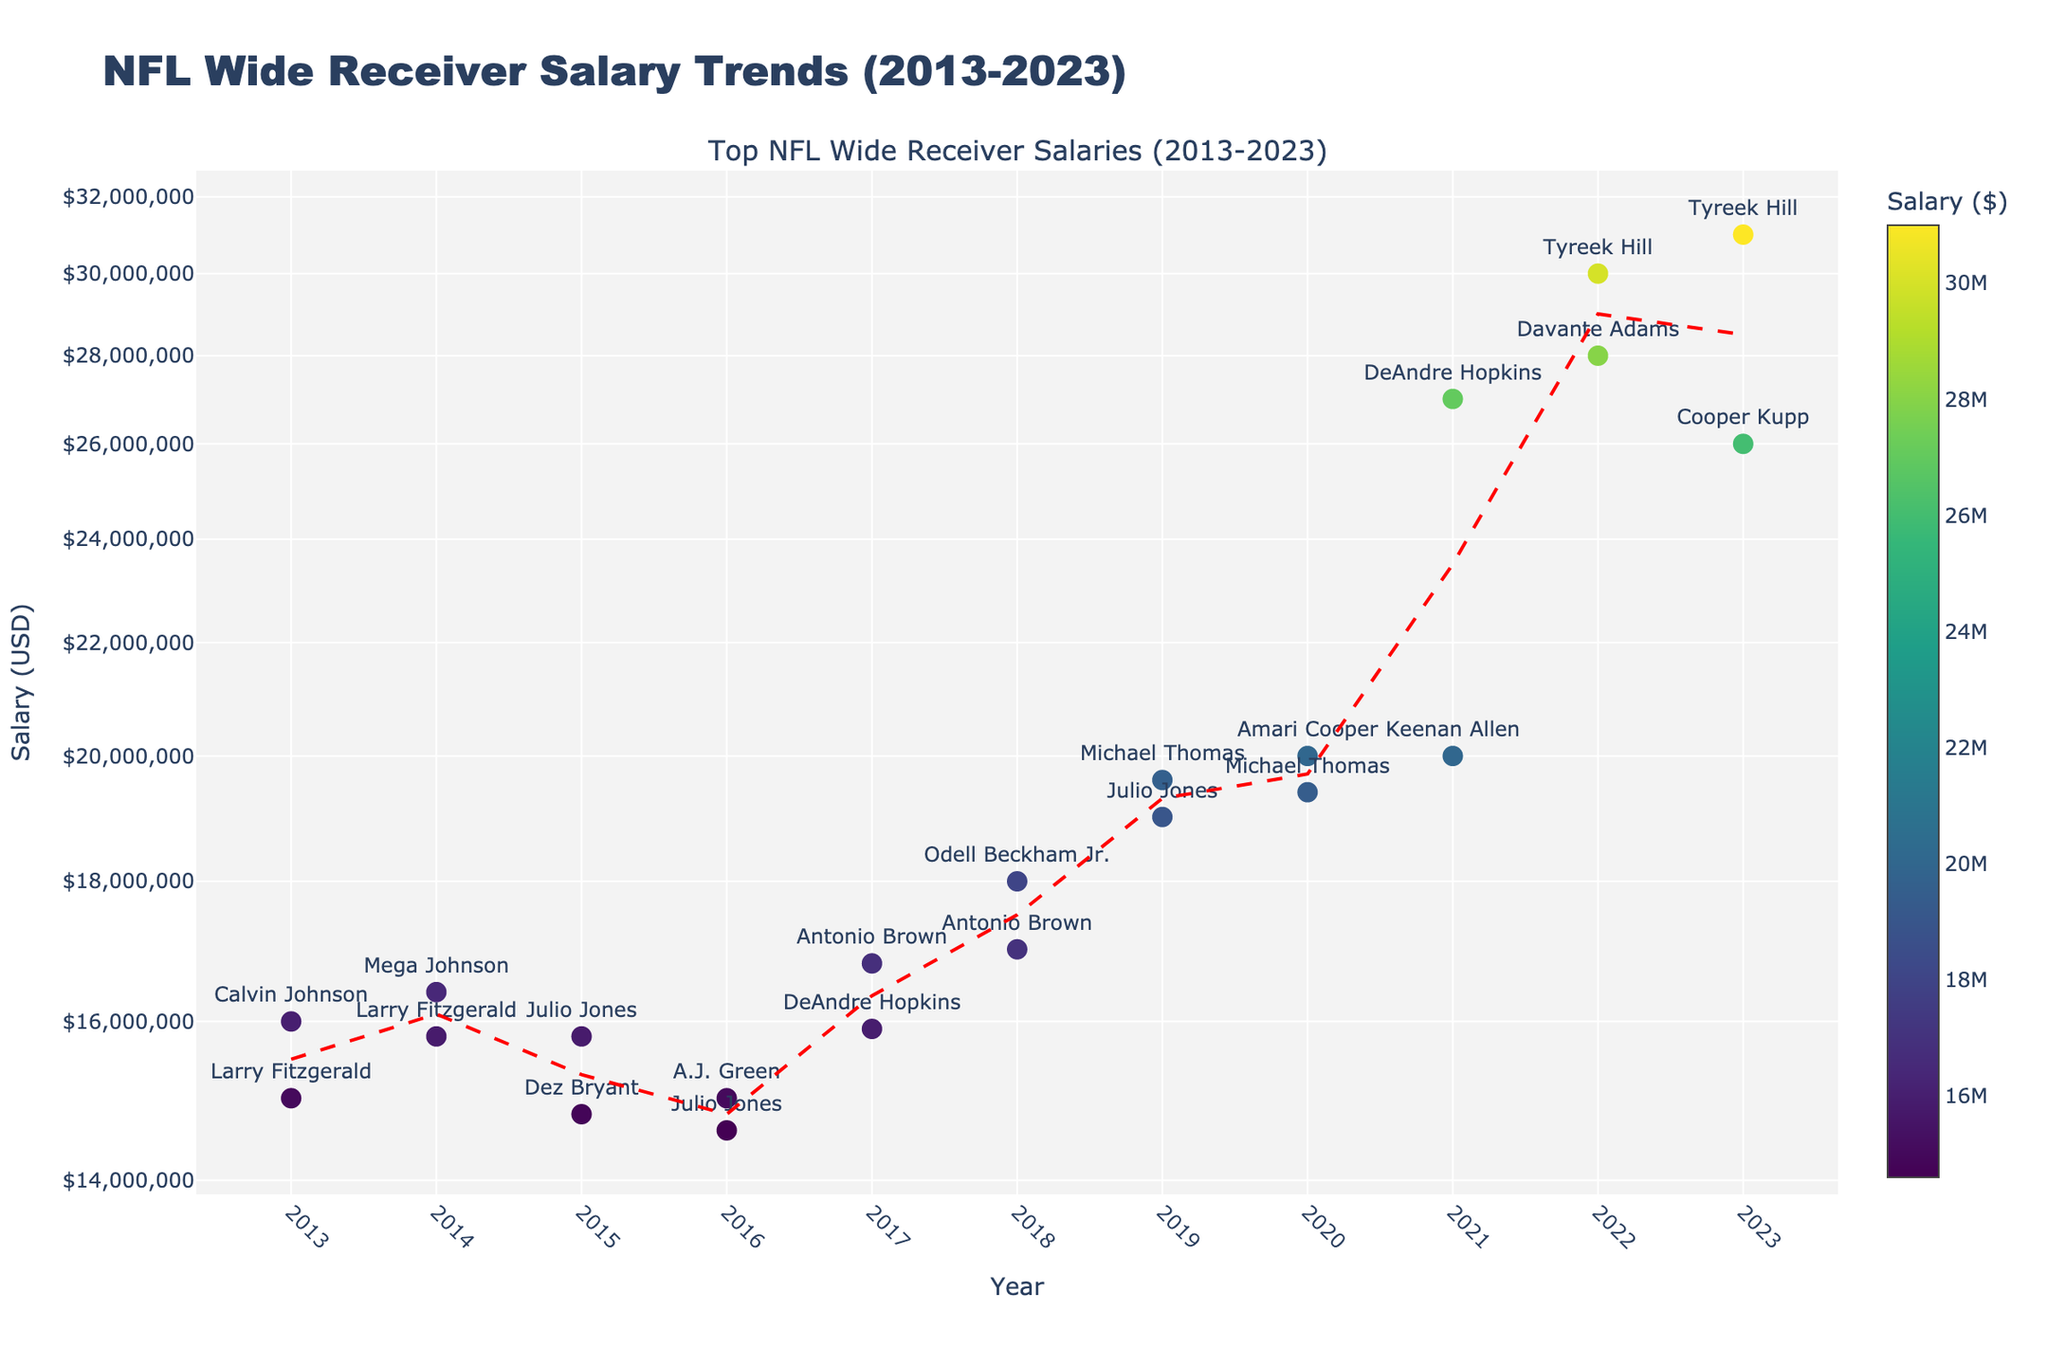How many years are represented in the figure? The x-axis represents different years with data points from 2013 to 2023. Counting these, there are a total of 11 years.
Answer: 11 Which player had the highest salary in 2022? To find the highest salary in 2022, look at the data points for that year and find the highest value. In 2022, Tyreek Hill had a salary of $30,000,000.
Answer: Tyreek Hill How much higher was Tyreek Hill's salary in 2023 compared to Keenan Allen's in 2021? Tyreek Hill's salary in 2023 was $31,000,000, and Keenan Allen's salary in 2021 was $20,000,000. The difference is $31,000,000 - $20,000,000 = $11,000,000.
Answer: $11,000,000 What is the median salary for wide receivers in 2019? To find the median salary for 2019, we look at the two salaries for that year: $19,600,000 (Michael Thomas) and $19,000,000 (Julio Jones). The median of these two values is ($19,600,000 + $19,000,000) / 2 = $19,300,000.
Answer: $19,300,000 Which year saw the largest increase in the median salary from the previous year? By comparing the median salaries year over year, we see significant increases in some years. From 2020 to 2021, the median rose from $19,400,000 to $27,000,000, an increase of $27,000,000 - $19,400,000 = $7,600,000, which is the largest increase.
Answer: 2021 What trend can you observe from the scatter plot and the trend line added for median salaries? The scatter plot and trend line indicate a general upward trend in wide receiver salaries from 2013 to 2023. The trend line shows how the median salary has been increasing over the years, represented by the dashed red line moving upwards.
Answer: Upward trend Which two players had the highest salaries in 2020 and what were their salaries? In 2020, the data points show Amari Cooper with a salary of $20,000,000 and Michael Thomas with a salary of $19,400,000.
Answer: Amari Cooper and Michael Thomas What is the color scale used to represent the salary levels, and how does it enhance the figure? The color scale 'Viridis' represents the salary levels, where different colors indicate different salary amounts. This enhances the figure by visually distinguishing between lower and higher salaries at a glance.
Answer: Viridis scale How does the plot use a log scale for the y-axis, and why might this be beneficial? The plot uses a logarithmic scale for the y-axis to better display a wide range of salary values and highlight percentage changes. It prevents higher salaries from skewing the lower values and makes the trends easier to observe.
Answer: Log scale for better visualization 